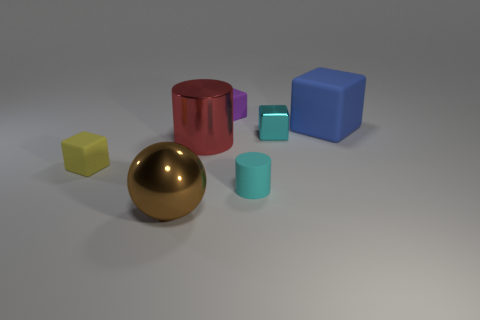Describe the texture and material of the objects in the scene. The objects in the image seem to have a smooth, slightly reflective surface, likely made of a rubber-like or plastic material, which gives them a matte finish.  Are there any shadows to indicate the light source? Yes, there are faint shadows cast behind the objects, suggesting the light source is coming from the front-left side of the image. 